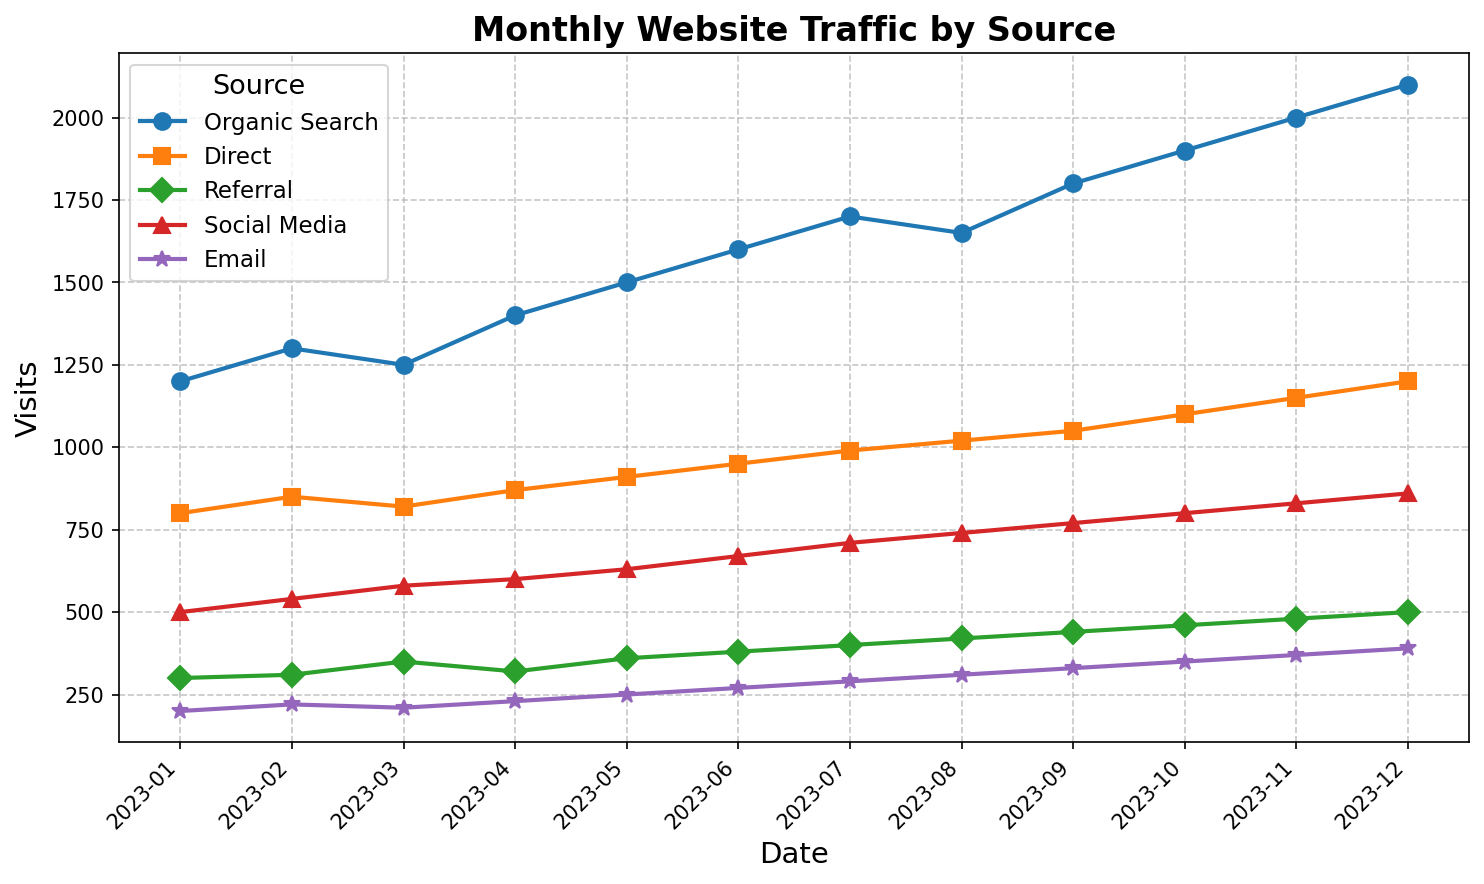Which source had the highest number of visits in January 2023? Look at January 2023 on the x-axis and identify the source with the highest point on the y-axis. The highest point corresponds to Organic Search with 1200 visits.
Answer: Organic Search How many total visits were there in May 2023 across all sources? Sum up the visits from all sources for May 2023. The values are Organic Search: 1500, Direct: 910, Referral: 360, Social Media: 630, Email: 250. So, 1500 + 910 + 360 + 630 + 250 = 3650.
Answer: 3650 Which source showed the most significant increase in visits from January to December 2023? To find this, subtract the January values from December values for each source. Organic Search increased from 1200 to 2100 (900), Direct from 800 to 1200 (400), Referral from 300 to 500 (200), Social Media from 500 to 860 (360), Email from 200 to 390 (190). Organic Search has the highest increase of 900.
Answer: Organic Search Between which two consecutive months did Social Media visits increase the most? Check the Social Media visits month-to-month. The differences are (540-500), (580-540), (600-580), (630-600), (670-630), (710-670), (740-710), (770-740), (800-770), (830-800), (860-830). The maximum increase is between December and November (30).
Answer: November to December 2023 What is the average number of visits from Email over the entire year? Sum the visits from Email for all months and divide by the number of months: (200+220+210+230+250+270+290+310+330+350+370+390)/12 = 3120/12 = 260.
Answer: 260 Which two sources had the closest number of visits in July 2023? Compare the values for July 2023: Organic Search: 1700, Direct: 990, Referral: 400, Social Media: 710, Email: 290. The closest pair is Social Media (710) and Referral (400), with a difference of 310.
Answer: Social Media and Referral From January to December, which source had a consistent upward trend without any decrease? Examine each source for upward trends without decreases. Only Organic Search steadily increases month over month.
Answer: Organic Search What was the difference in visits for Direct between May and August 2023? Subtract the number of visits in May from those in August for Direct: 1020 - 910 = 110.
Answer: 110 In which month were the visits for Referral at their highest? Find the peak on the Referral line. This peak occurs in December with 500 visits.
Answer: December 2023 